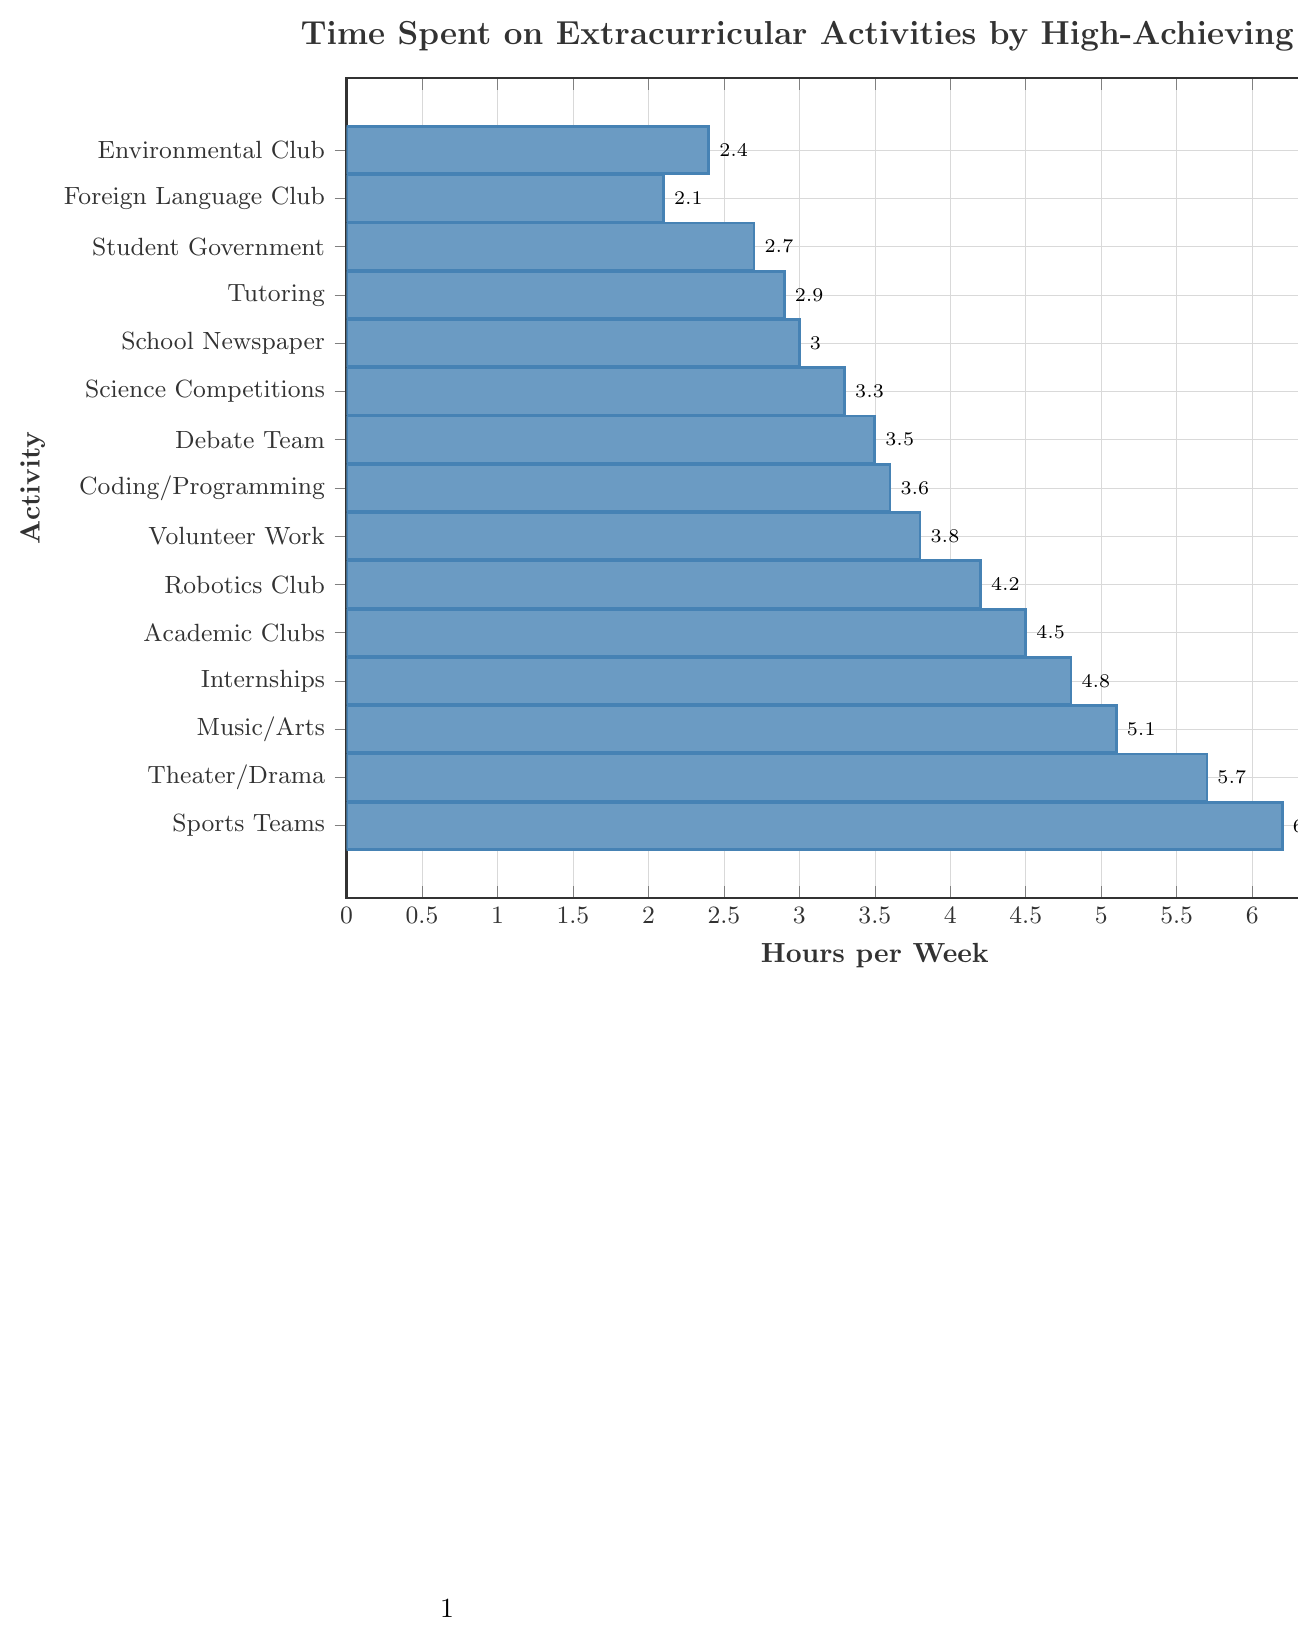What activity do high-achieving students spend the most time on? The bar chart shows the length of the bars corresponding to each activity. The longest bar represents Sports Teams, indicating the highest time spent.
Answer: Sports Teams Which extracurricular activity do high-achieving students spend the least time on? The bar chart shows the shortest bar which corresponds to Foreign Language Club.
Answer: Foreign Language Club How much more time is spent on Theater/Drama compared to Science Competitions per week? Theater/Drama has a bar representing 5.7 hours and Science Competitions have a bar representing 3.3 hours. Subtracting these values: 5.7 - 3.3 = 2.4 hours more.
Answer: 2.4 hours What is the total time spent on Music/Arts and Theater/Drama combined per week? Add the hours spent on Music/Arts (5.1 hours) and Theater/Drama (5.7 hours): 5.1 + 5.7 = 10.8 hours.
Answer: 10.8 hours Which activity has a bar length closest to 3.0 hours per week? By observing the bars, School Newspaper has a bar length of 3.0 hours.
Answer: School Newspaper Rank the activities in descending order based on the time spent per week. List the activities based on the length of the bars from the longest to the shortest. Sports Teams (6.2), Theater/Drama (5.7), Music/Arts (5.1), Internships (4.8), Academic Clubs (4.5), Robotics Club (4.2), Volunteer Work (3.8), Coding/Programming (3.6), Debate Team (3.5), Science Competitions (3.3), School Newspaper (3.0), Tutoring (2.9), Student Government (2.7), Environmental Club (2.4), Foreign Language Club (2.1).
Answer: Sports Teams, Theater/Drama, Music/Arts, Internships, Academic Clubs, Robotics Club, Volunteer Work, Coding/Programming, Debate Team, Science Competitions, School Newspaper, Tutoring, Student Government, Environmental Club, Foreign Language Club What is the difference in time spent between the activity with the most time and the least time? The activity with the most time is Sports Teams (6.2 hours) and the least is Foreign Language Club (2.1 hours). Difference: 6.2 - 2.1 = 4.1 hours.
Answer: 4.1 hours Does the Robotics Club or the Debate Team have more hours spent per week? Comparing the bars, Robotics Club has a bar representing 4.2 hours and Debate Team has a bar representing 3.5 hours. Robotics Club has more hours.
Answer: Robotics Club What is the average time spent on all activities per week? Sum all the hours and divide by the number of activities. Sum: 2.4 + 2.1 + 2.7 + 2.9 + 3.0 + 3.3 + 3.5 + 3.6 + 3.8 + 4.2 + 4.5 + 4.8 + 5.1 + 5.7 + 6.2 = 57.8. Number of activities: 15. Average: 57.8/15 = 3.85 hours.
Answer: 3.85 hours What activity has roughly the median time spent per week? Rank the activities in ascending order of time spent and find the middle value. The ordered list is: Foreign Language Club (2.1), Environmental Club (2.4), Student Government (2.7), Tutoring (2.9), School Newspaper (3.0), Science Competitions (3.3), Debate Team (3.5), Coding/Programming (3.6), Volunteer Work (3.8), Robotics Club (4.2), Academic Clubs (4.5), Internships (4.8), Music/Arts (5.1), Theater/Drama (5.7), Sports Teams (6.2). The median value is Coding/Programming (3.6) as it is the 8th value in an ordered list of 15.
Answer: Coding/Programming 